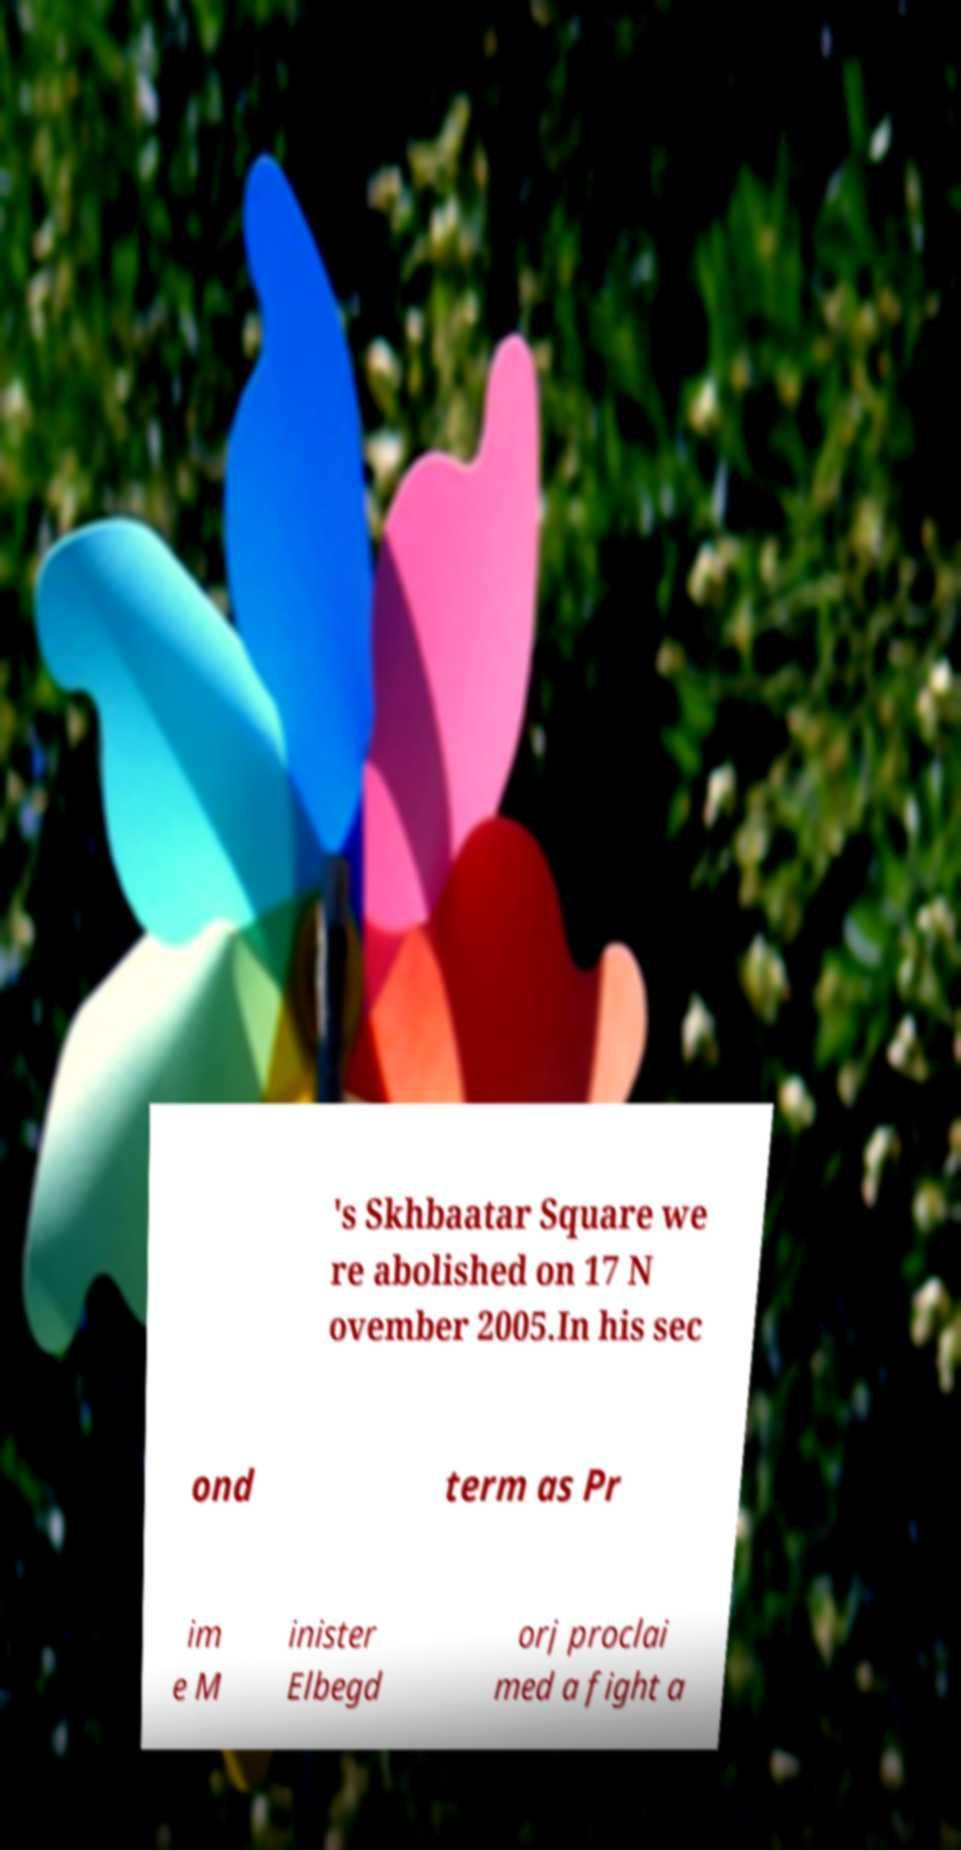I need the written content from this picture converted into text. Can you do that? 's Skhbaatar Square we re abolished on 17 N ovember 2005.In his sec ond term as Pr im e M inister Elbegd orj proclai med a fight a 